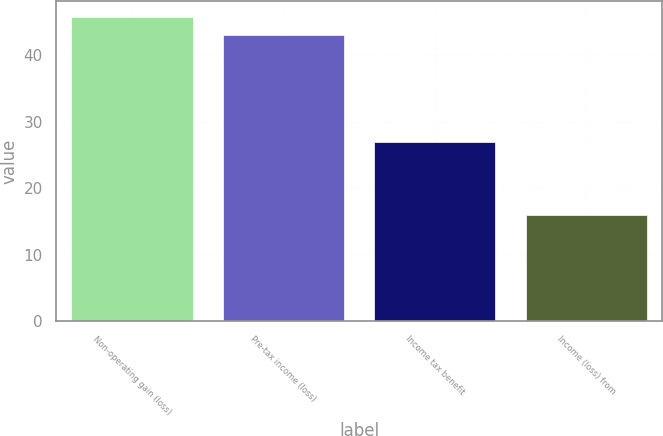<chart> <loc_0><loc_0><loc_500><loc_500><bar_chart><fcel>Non-operating gain (loss)<fcel>Pre-tax income (loss)<fcel>Income tax benefit<fcel>Income (loss) from<nl><fcel>45.8<fcel>43<fcel>27<fcel>16<nl></chart> 